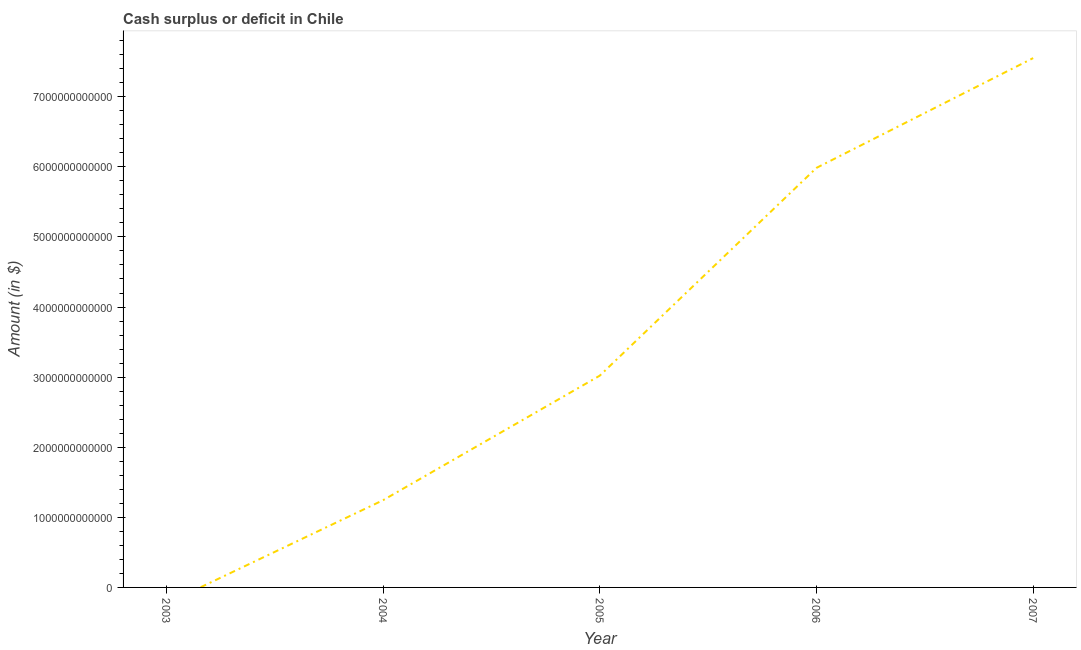What is the cash surplus or deficit in 2003?
Provide a short and direct response. 0. Across all years, what is the maximum cash surplus or deficit?
Provide a short and direct response. 7.55e+12. Across all years, what is the minimum cash surplus or deficit?
Your answer should be compact. 0. In which year was the cash surplus or deficit maximum?
Give a very brief answer. 2007. What is the sum of the cash surplus or deficit?
Offer a very short reply. 1.78e+13. What is the difference between the cash surplus or deficit in 2004 and 2005?
Give a very brief answer. -1.78e+12. What is the average cash surplus or deficit per year?
Make the answer very short. 3.56e+12. What is the median cash surplus or deficit?
Your response must be concise. 3.02e+12. What is the ratio of the cash surplus or deficit in 2004 to that in 2007?
Provide a succinct answer. 0.16. Is the cash surplus or deficit in 2005 less than that in 2007?
Your answer should be compact. Yes. Is the difference between the cash surplus or deficit in 2004 and 2006 greater than the difference between any two years?
Make the answer very short. No. What is the difference between the highest and the second highest cash surplus or deficit?
Offer a terse response. 1.57e+12. Is the sum of the cash surplus or deficit in 2004 and 2007 greater than the maximum cash surplus or deficit across all years?
Offer a very short reply. Yes. What is the difference between the highest and the lowest cash surplus or deficit?
Your answer should be very brief. 7.55e+12. In how many years, is the cash surplus or deficit greater than the average cash surplus or deficit taken over all years?
Make the answer very short. 2. Does the cash surplus or deficit monotonically increase over the years?
Offer a terse response. Yes. How many years are there in the graph?
Offer a terse response. 5. What is the difference between two consecutive major ticks on the Y-axis?
Your answer should be compact. 1.00e+12. Does the graph contain grids?
Your answer should be very brief. No. What is the title of the graph?
Provide a succinct answer. Cash surplus or deficit in Chile. What is the label or title of the Y-axis?
Your answer should be compact. Amount (in $). What is the Amount (in $) in 2003?
Your answer should be compact. 0. What is the Amount (in $) of 2004?
Your response must be concise. 1.24e+12. What is the Amount (in $) of 2005?
Your answer should be very brief. 3.02e+12. What is the Amount (in $) of 2006?
Offer a very short reply. 5.98e+12. What is the Amount (in $) of 2007?
Keep it short and to the point. 7.55e+12. What is the difference between the Amount (in $) in 2004 and 2005?
Your response must be concise. -1.78e+12. What is the difference between the Amount (in $) in 2004 and 2006?
Make the answer very short. -4.74e+12. What is the difference between the Amount (in $) in 2004 and 2007?
Give a very brief answer. -6.31e+12. What is the difference between the Amount (in $) in 2005 and 2006?
Your response must be concise. -2.96e+12. What is the difference between the Amount (in $) in 2005 and 2007?
Ensure brevity in your answer.  -4.53e+12. What is the difference between the Amount (in $) in 2006 and 2007?
Offer a very short reply. -1.57e+12. What is the ratio of the Amount (in $) in 2004 to that in 2005?
Your answer should be compact. 0.41. What is the ratio of the Amount (in $) in 2004 to that in 2006?
Provide a succinct answer. 0.21. What is the ratio of the Amount (in $) in 2004 to that in 2007?
Ensure brevity in your answer.  0.17. What is the ratio of the Amount (in $) in 2005 to that in 2006?
Give a very brief answer. 0.51. What is the ratio of the Amount (in $) in 2005 to that in 2007?
Ensure brevity in your answer.  0.4. What is the ratio of the Amount (in $) in 2006 to that in 2007?
Your response must be concise. 0.79. 